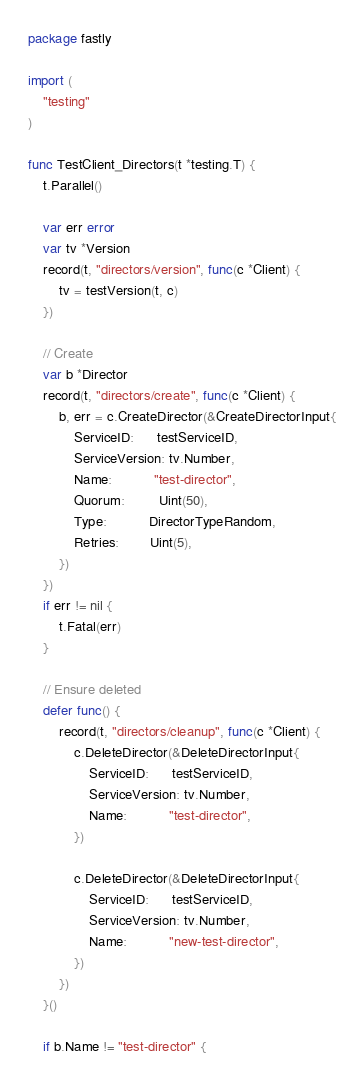<code> <loc_0><loc_0><loc_500><loc_500><_Go_>package fastly

import (
	"testing"
)

func TestClient_Directors(t *testing.T) {
	t.Parallel()

	var err error
	var tv *Version
	record(t, "directors/version", func(c *Client) {
		tv = testVersion(t, c)
	})

	// Create
	var b *Director
	record(t, "directors/create", func(c *Client) {
		b, err = c.CreateDirector(&CreateDirectorInput{
			ServiceID:      testServiceID,
			ServiceVersion: tv.Number,
			Name:           "test-director",
			Quorum:         Uint(50),
			Type:           DirectorTypeRandom,
			Retries:        Uint(5),
		})
	})
	if err != nil {
		t.Fatal(err)
	}

	// Ensure deleted
	defer func() {
		record(t, "directors/cleanup", func(c *Client) {
			c.DeleteDirector(&DeleteDirectorInput{
				ServiceID:      testServiceID,
				ServiceVersion: tv.Number,
				Name:           "test-director",
			})

			c.DeleteDirector(&DeleteDirectorInput{
				ServiceID:      testServiceID,
				ServiceVersion: tv.Number,
				Name:           "new-test-director",
			})
		})
	}()

	if b.Name != "test-director" {</code> 